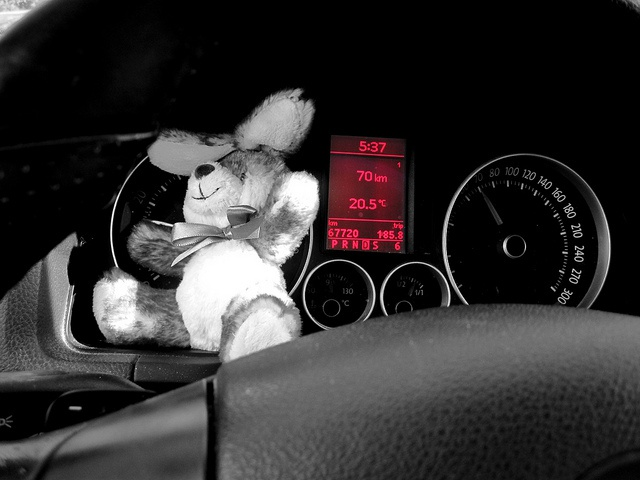Describe the objects in this image and their specific colors. I can see a teddy bear in darkgray, lightgray, gray, and black tones in this image. 